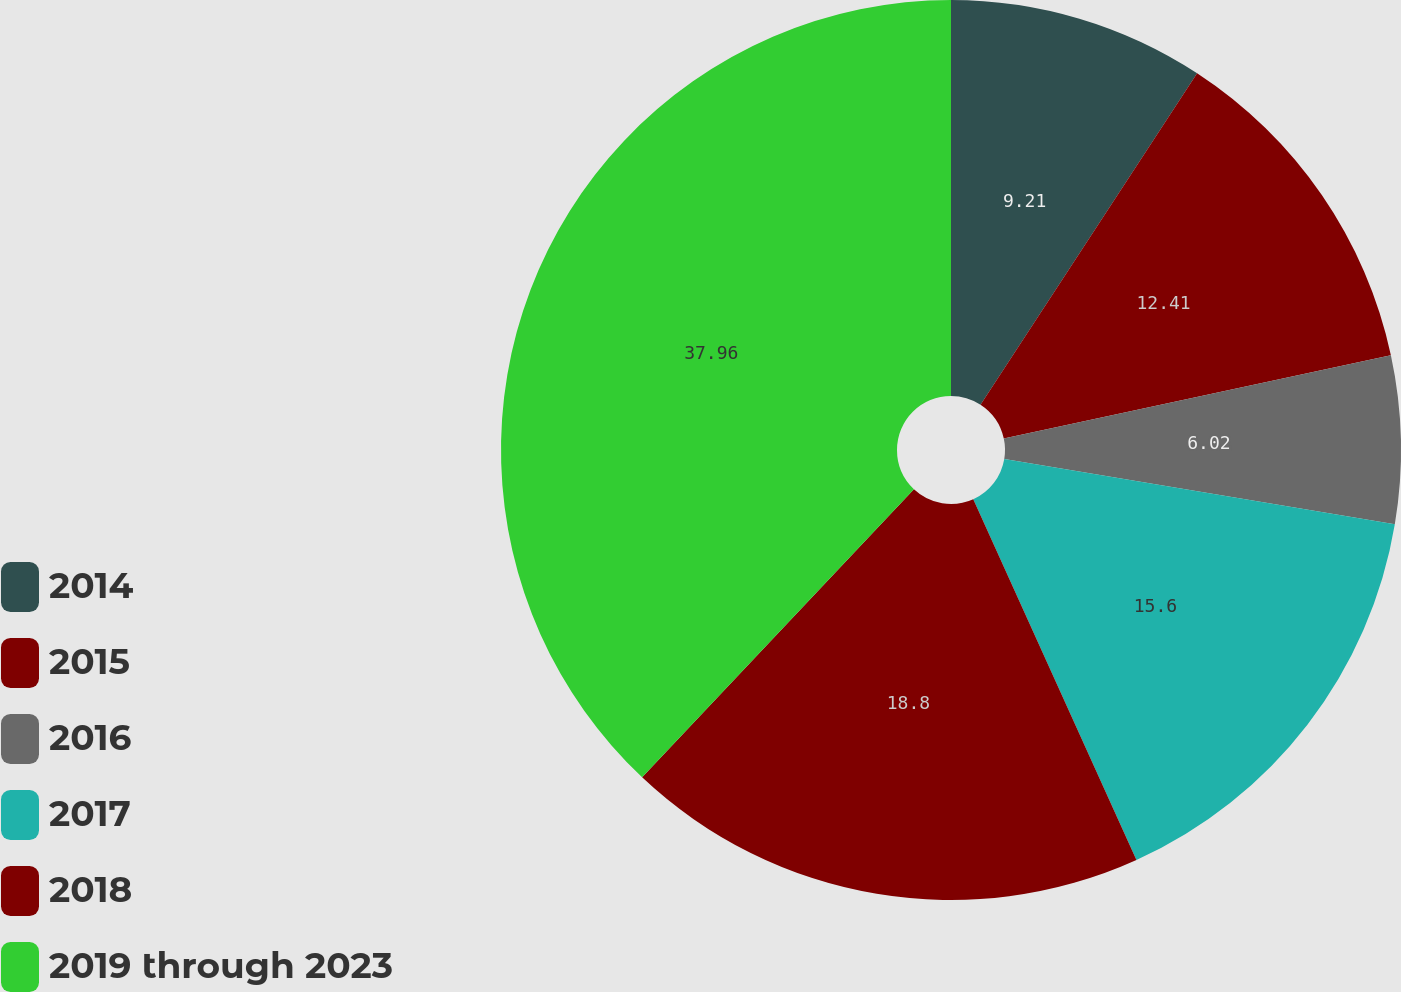Convert chart. <chart><loc_0><loc_0><loc_500><loc_500><pie_chart><fcel>2014<fcel>2015<fcel>2016<fcel>2017<fcel>2018<fcel>2019 through 2023<nl><fcel>9.21%<fcel>12.41%<fcel>6.02%<fcel>15.6%<fcel>18.8%<fcel>37.96%<nl></chart> 